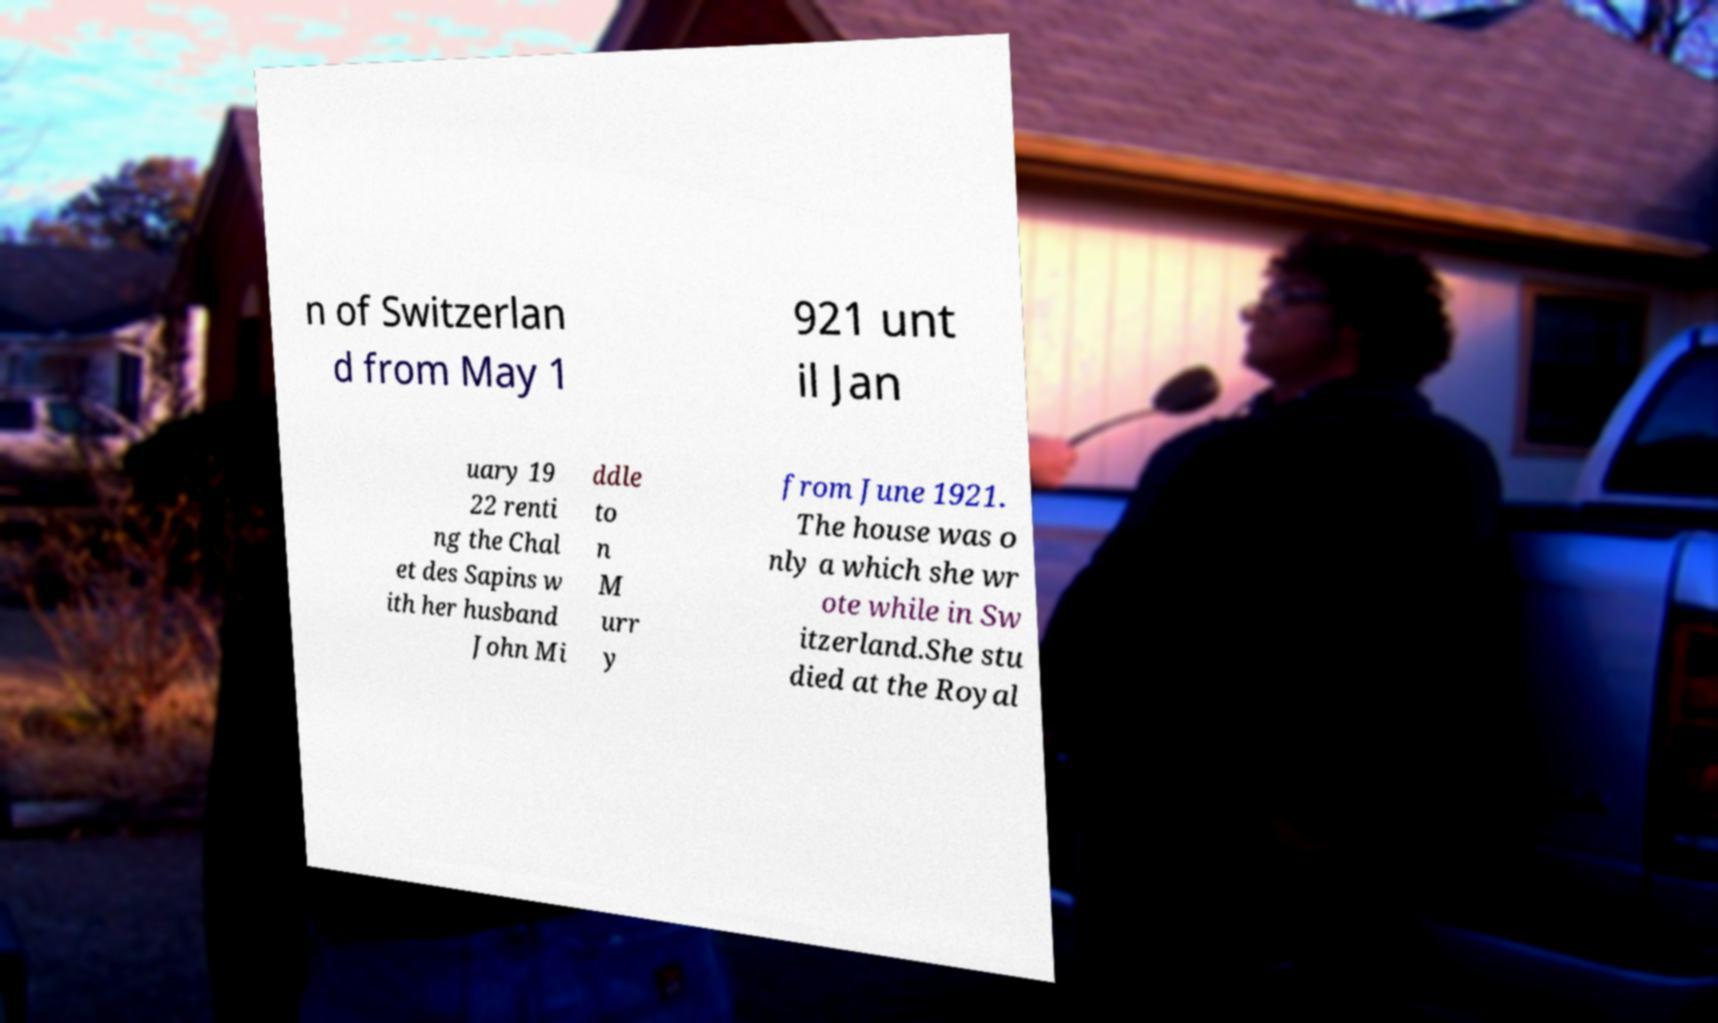Can you read and provide the text displayed in the image?This photo seems to have some interesting text. Can you extract and type it out for me? n of Switzerlan d from May 1 921 unt il Jan uary 19 22 renti ng the Chal et des Sapins w ith her husband John Mi ddle to n M urr y from June 1921. The house was o nly a which she wr ote while in Sw itzerland.She stu died at the Royal 